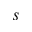<formula> <loc_0><loc_0><loc_500><loc_500>s</formula> 